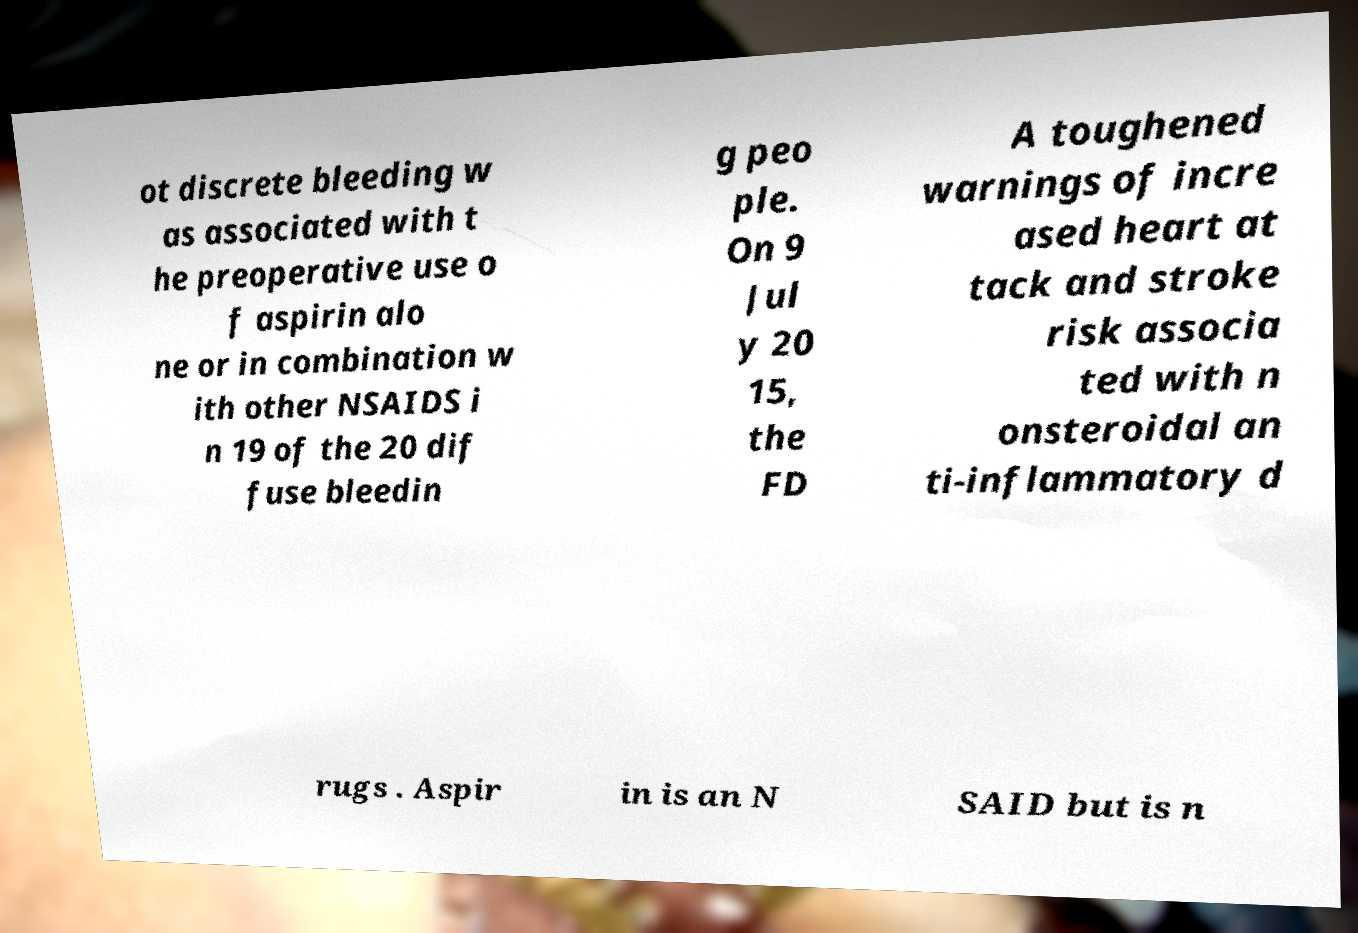Can you read and provide the text displayed in the image?This photo seems to have some interesting text. Can you extract and type it out for me? ot discrete bleeding w as associated with t he preoperative use o f aspirin alo ne or in combination w ith other NSAIDS i n 19 of the 20 dif fuse bleedin g peo ple. On 9 Jul y 20 15, the FD A toughened warnings of incre ased heart at tack and stroke risk associa ted with n onsteroidal an ti-inflammatory d rugs . Aspir in is an N SAID but is n 